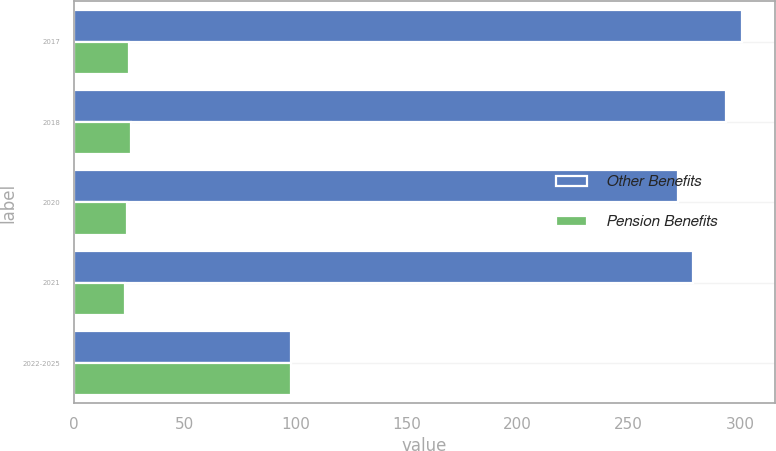Convert chart to OTSL. <chart><loc_0><loc_0><loc_500><loc_500><stacked_bar_chart><ecel><fcel>2017<fcel>2018<fcel>2020<fcel>2021<fcel>2022-2025<nl><fcel>Other Benefits<fcel>301<fcel>294<fcel>272<fcel>279<fcel>98<nl><fcel>Pension Benefits<fcel>25<fcel>26<fcel>24<fcel>23<fcel>98<nl></chart> 